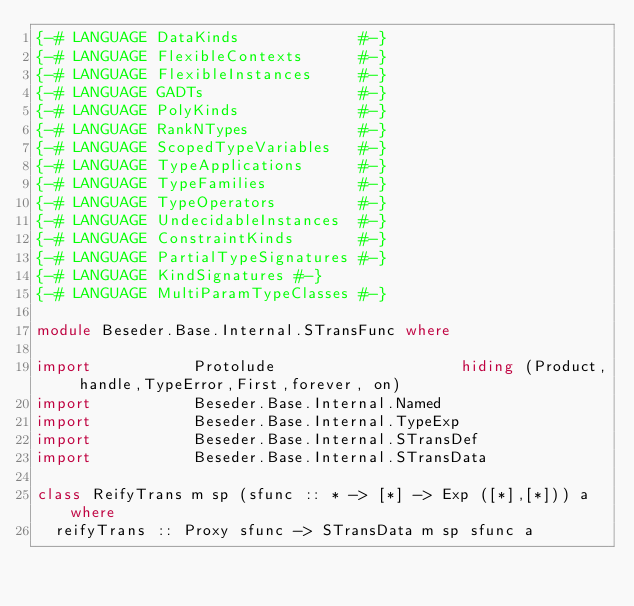Convert code to text. <code><loc_0><loc_0><loc_500><loc_500><_Haskell_>{-# LANGUAGE DataKinds             #-}
{-# LANGUAGE FlexibleContexts      #-}
{-# LANGUAGE FlexibleInstances     #-}
{-# LANGUAGE GADTs                 #-}
{-# LANGUAGE PolyKinds             #-}
{-# LANGUAGE RankNTypes            #-}
{-# LANGUAGE ScopedTypeVariables   #-}
{-# LANGUAGE TypeApplications      #-}
{-# LANGUAGE TypeFamilies          #-}
{-# LANGUAGE TypeOperators         #-}
{-# LANGUAGE UndecidableInstances  #-}
{-# LANGUAGE ConstraintKinds       #-}
{-# LANGUAGE PartialTypeSignatures #-}
{-# LANGUAGE KindSignatures #-}
{-# LANGUAGE MultiParamTypeClasses #-}

module Beseder.Base.Internal.STransFunc where

import           Protolude                    hiding (Product, handle,TypeError,First,forever, on)
import           Beseder.Base.Internal.Named
import           Beseder.Base.Internal.TypeExp
import           Beseder.Base.Internal.STransDef
import           Beseder.Base.Internal.STransData

class ReifyTrans m sp (sfunc :: * -> [*] -> Exp ([*],[*])) a where
  reifyTrans :: Proxy sfunc -> STransData m sp sfunc a 
</code> 